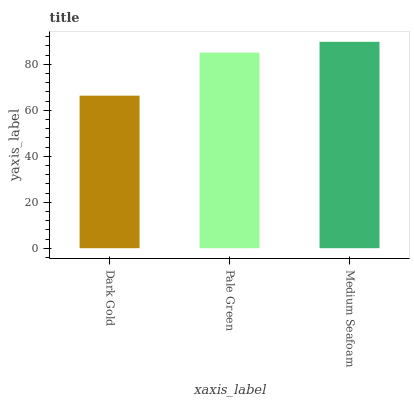Is Dark Gold the minimum?
Answer yes or no. Yes. Is Medium Seafoam the maximum?
Answer yes or no. Yes. Is Pale Green the minimum?
Answer yes or no. No. Is Pale Green the maximum?
Answer yes or no. No. Is Pale Green greater than Dark Gold?
Answer yes or no. Yes. Is Dark Gold less than Pale Green?
Answer yes or no. Yes. Is Dark Gold greater than Pale Green?
Answer yes or no. No. Is Pale Green less than Dark Gold?
Answer yes or no. No. Is Pale Green the high median?
Answer yes or no. Yes. Is Pale Green the low median?
Answer yes or no. Yes. Is Dark Gold the high median?
Answer yes or no. No. Is Medium Seafoam the low median?
Answer yes or no. No. 